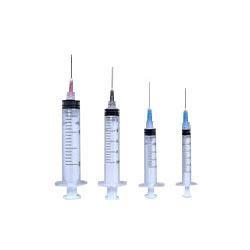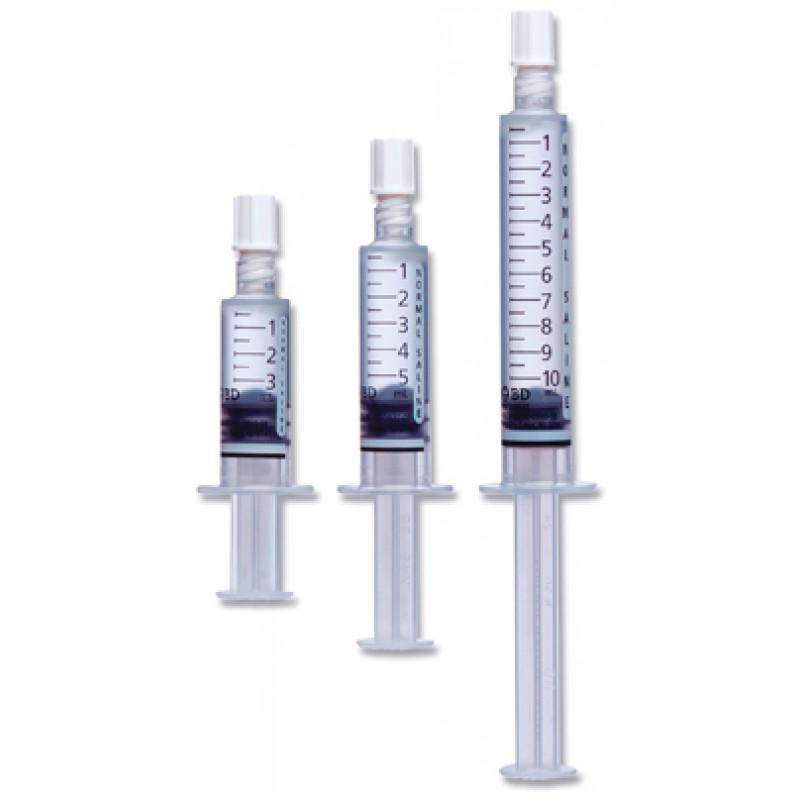The first image is the image on the left, the second image is the image on the right. Assess this claim about the two images: "There is exactly one syringe in the left image.". Correct or not? Answer yes or no. No. The first image is the image on the left, the second image is the image on the right. Analyze the images presented: Is the assertion "There are 3 or fewer syringes total." valid? Answer yes or no. No. 